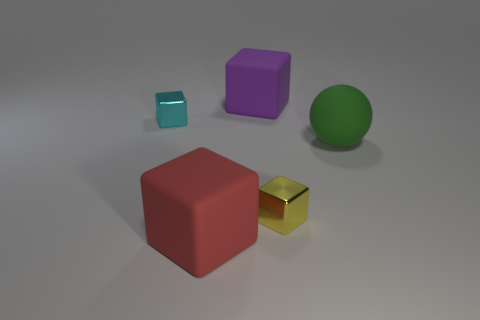Can you describe the lighting and shadows in the scene? The scene is illuminated by a diffuse overhead light source which casts soft shadows. Objects have distinct but blurry shadows that appear most prominently to their right side, indicating a light source slightly to the left of the scene. 